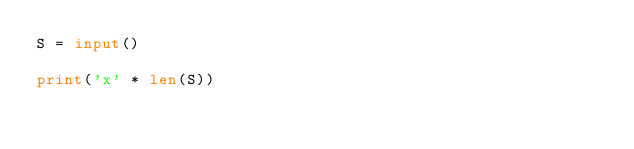<code> <loc_0><loc_0><loc_500><loc_500><_Python_>S = input()

print('x' * len(S))</code> 